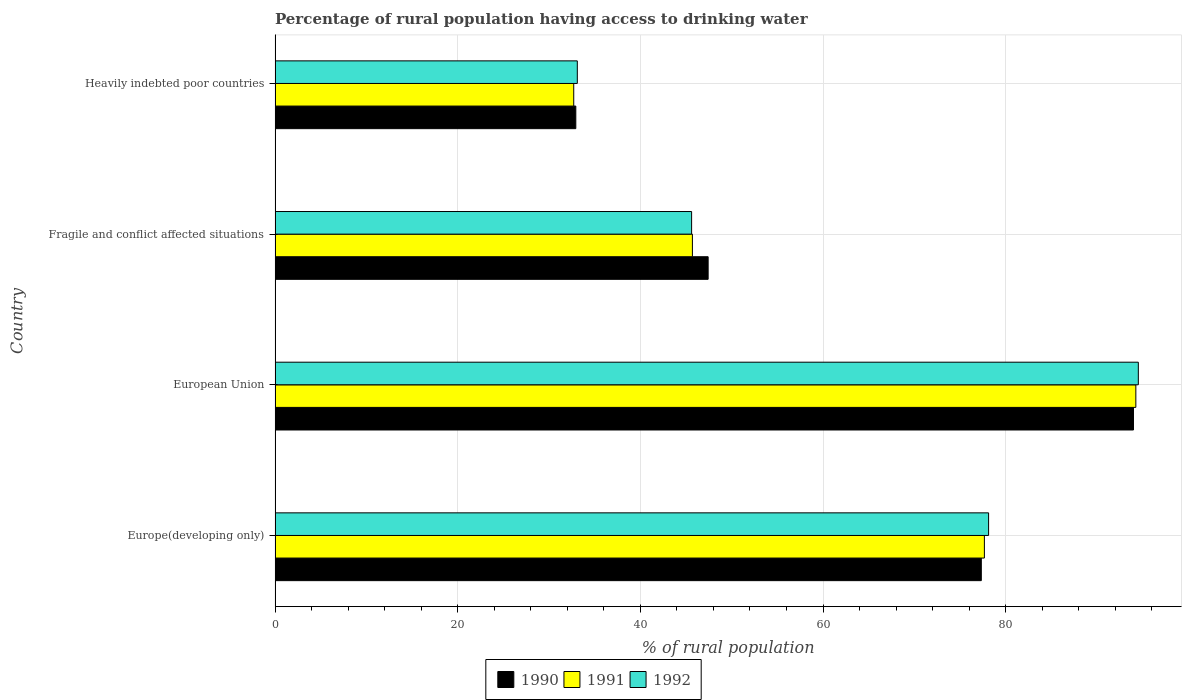How many bars are there on the 1st tick from the top?
Ensure brevity in your answer.  3. How many bars are there on the 2nd tick from the bottom?
Your response must be concise. 3. What is the label of the 3rd group of bars from the top?
Provide a short and direct response. European Union. What is the percentage of rural population having access to drinking water in 1991 in European Union?
Offer a very short reply. 94.25. Across all countries, what is the maximum percentage of rural population having access to drinking water in 1991?
Provide a short and direct response. 94.25. Across all countries, what is the minimum percentage of rural population having access to drinking water in 1990?
Ensure brevity in your answer.  32.93. In which country was the percentage of rural population having access to drinking water in 1992 minimum?
Ensure brevity in your answer.  Heavily indebted poor countries. What is the total percentage of rural population having access to drinking water in 1990 in the graph?
Ensure brevity in your answer.  251.68. What is the difference between the percentage of rural population having access to drinking water in 1991 in Fragile and conflict affected situations and that in Heavily indebted poor countries?
Offer a very short reply. 12.99. What is the difference between the percentage of rural population having access to drinking water in 1990 in European Union and the percentage of rural population having access to drinking water in 1992 in Fragile and conflict affected situations?
Keep it short and to the point. 48.38. What is the average percentage of rural population having access to drinking water in 1991 per country?
Your answer should be very brief. 62.58. What is the difference between the percentage of rural population having access to drinking water in 1992 and percentage of rural population having access to drinking water in 1991 in Fragile and conflict affected situations?
Provide a succinct answer. -0.09. In how many countries, is the percentage of rural population having access to drinking water in 1990 greater than 16 %?
Offer a very short reply. 4. What is the ratio of the percentage of rural population having access to drinking water in 1990 in European Union to that in Fragile and conflict affected situations?
Give a very brief answer. 1.98. Is the difference between the percentage of rural population having access to drinking water in 1992 in Fragile and conflict affected situations and Heavily indebted poor countries greater than the difference between the percentage of rural population having access to drinking water in 1991 in Fragile and conflict affected situations and Heavily indebted poor countries?
Provide a short and direct response. No. What is the difference between the highest and the second highest percentage of rural population having access to drinking water in 1990?
Offer a terse response. 16.66. What is the difference between the highest and the lowest percentage of rural population having access to drinking water in 1991?
Provide a succinct answer. 61.55. In how many countries, is the percentage of rural population having access to drinking water in 1990 greater than the average percentage of rural population having access to drinking water in 1990 taken over all countries?
Ensure brevity in your answer.  2. Is the sum of the percentage of rural population having access to drinking water in 1991 in European Union and Heavily indebted poor countries greater than the maximum percentage of rural population having access to drinking water in 1992 across all countries?
Keep it short and to the point. Yes. What does the 2nd bar from the bottom in Fragile and conflict affected situations represents?
Your answer should be compact. 1991. Is it the case that in every country, the sum of the percentage of rural population having access to drinking water in 1992 and percentage of rural population having access to drinking water in 1991 is greater than the percentage of rural population having access to drinking water in 1990?
Provide a short and direct response. Yes. Are all the bars in the graph horizontal?
Your answer should be compact. Yes. What is the difference between two consecutive major ticks on the X-axis?
Your answer should be very brief. 20. Are the values on the major ticks of X-axis written in scientific E-notation?
Keep it short and to the point. No. Does the graph contain grids?
Your response must be concise. Yes. Where does the legend appear in the graph?
Give a very brief answer. Bottom center. How many legend labels are there?
Offer a terse response. 3. How are the legend labels stacked?
Offer a very short reply. Horizontal. What is the title of the graph?
Make the answer very short. Percentage of rural population having access to drinking water. Does "2009" appear as one of the legend labels in the graph?
Your answer should be very brief. No. What is the label or title of the X-axis?
Your response must be concise. % of rural population. What is the % of rural population of 1990 in Europe(developing only)?
Ensure brevity in your answer.  77.33. What is the % of rural population in 1991 in Europe(developing only)?
Make the answer very short. 77.67. What is the % of rural population in 1992 in Europe(developing only)?
Provide a short and direct response. 78.13. What is the % of rural population of 1990 in European Union?
Keep it short and to the point. 93.99. What is the % of rural population of 1991 in European Union?
Provide a short and direct response. 94.25. What is the % of rural population in 1992 in European Union?
Offer a terse response. 94.53. What is the % of rural population of 1990 in Fragile and conflict affected situations?
Keep it short and to the point. 47.42. What is the % of rural population of 1991 in Fragile and conflict affected situations?
Make the answer very short. 45.7. What is the % of rural population in 1992 in Fragile and conflict affected situations?
Offer a terse response. 45.61. What is the % of rural population of 1990 in Heavily indebted poor countries?
Keep it short and to the point. 32.93. What is the % of rural population in 1991 in Heavily indebted poor countries?
Provide a succinct answer. 32.7. What is the % of rural population of 1992 in Heavily indebted poor countries?
Offer a terse response. 33.09. Across all countries, what is the maximum % of rural population in 1990?
Offer a terse response. 93.99. Across all countries, what is the maximum % of rural population in 1991?
Offer a very short reply. 94.25. Across all countries, what is the maximum % of rural population of 1992?
Give a very brief answer. 94.53. Across all countries, what is the minimum % of rural population of 1990?
Offer a terse response. 32.93. Across all countries, what is the minimum % of rural population in 1991?
Offer a very short reply. 32.7. Across all countries, what is the minimum % of rural population in 1992?
Make the answer very short. 33.09. What is the total % of rural population of 1990 in the graph?
Provide a short and direct response. 251.68. What is the total % of rural population in 1991 in the graph?
Your response must be concise. 250.32. What is the total % of rural population in 1992 in the graph?
Provide a short and direct response. 251.36. What is the difference between the % of rural population in 1990 in Europe(developing only) and that in European Union?
Keep it short and to the point. -16.66. What is the difference between the % of rural population in 1991 in Europe(developing only) and that in European Union?
Provide a succinct answer. -16.59. What is the difference between the % of rural population in 1992 in Europe(developing only) and that in European Union?
Ensure brevity in your answer.  -16.4. What is the difference between the % of rural population in 1990 in Europe(developing only) and that in Fragile and conflict affected situations?
Make the answer very short. 29.91. What is the difference between the % of rural population of 1991 in Europe(developing only) and that in Fragile and conflict affected situations?
Give a very brief answer. 31.97. What is the difference between the % of rural population in 1992 in Europe(developing only) and that in Fragile and conflict affected situations?
Ensure brevity in your answer.  32.52. What is the difference between the % of rural population in 1990 in Europe(developing only) and that in Heavily indebted poor countries?
Ensure brevity in your answer.  44.4. What is the difference between the % of rural population in 1991 in Europe(developing only) and that in Heavily indebted poor countries?
Offer a very short reply. 44.97. What is the difference between the % of rural population of 1992 in Europe(developing only) and that in Heavily indebted poor countries?
Ensure brevity in your answer.  45.04. What is the difference between the % of rural population of 1990 in European Union and that in Fragile and conflict affected situations?
Your answer should be compact. 46.57. What is the difference between the % of rural population of 1991 in European Union and that in Fragile and conflict affected situations?
Keep it short and to the point. 48.56. What is the difference between the % of rural population of 1992 in European Union and that in Fragile and conflict affected situations?
Your answer should be compact. 48.92. What is the difference between the % of rural population in 1990 in European Union and that in Heavily indebted poor countries?
Your response must be concise. 61.06. What is the difference between the % of rural population of 1991 in European Union and that in Heavily indebted poor countries?
Offer a terse response. 61.55. What is the difference between the % of rural population of 1992 in European Union and that in Heavily indebted poor countries?
Your answer should be very brief. 61.43. What is the difference between the % of rural population in 1990 in Fragile and conflict affected situations and that in Heavily indebted poor countries?
Your answer should be compact. 14.49. What is the difference between the % of rural population of 1991 in Fragile and conflict affected situations and that in Heavily indebted poor countries?
Provide a short and direct response. 12.99. What is the difference between the % of rural population in 1992 in Fragile and conflict affected situations and that in Heavily indebted poor countries?
Provide a short and direct response. 12.52. What is the difference between the % of rural population of 1990 in Europe(developing only) and the % of rural population of 1991 in European Union?
Provide a succinct answer. -16.92. What is the difference between the % of rural population in 1990 in Europe(developing only) and the % of rural population in 1992 in European Union?
Your response must be concise. -17.19. What is the difference between the % of rural population of 1991 in Europe(developing only) and the % of rural population of 1992 in European Union?
Give a very brief answer. -16.86. What is the difference between the % of rural population of 1990 in Europe(developing only) and the % of rural population of 1991 in Fragile and conflict affected situations?
Offer a very short reply. 31.64. What is the difference between the % of rural population of 1990 in Europe(developing only) and the % of rural population of 1992 in Fragile and conflict affected situations?
Provide a short and direct response. 31.72. What is the difference between the % of rural population of 1991 in Europe(developing only) and the % of rural population of 1992 in Fragile and conflict affected situations?
Your answer should be very brief. 32.06. What is the difference between the % of rural population of 1990 in Europe(developing only) and the % of rural population of 1991 in Heavily indebted poor countries?
Provide a short and direct response. 44.63. What is the difference between the % of rural population in 1990 in Europe(developing only) and the % of rural population in 1992 in Heavily indebted poor countries?
Your response must be concise. 44.24. What is the difference between the % of rural population of 1991 in Europe(developing only) and the % of rural population of 1992 in Heavily indebted poor countries?
Provide a short and direct response. 44.57. What is the difference between the % of rural population of 1990 in European Union and the % of rural population of 1991 in Fragile and conflict affected situations?
Your response must be concise. 48.3. What is the difference between the % of rural population of 1990 in European Union and the % of rural population of 1992 in Fragile and conflict affected situations?
Your response must be concise. 48.38. What is the difference between the % of rural population in 1991 in European Union and the % of rural population in 1992 in Fragile and conflict affected situations?
Ensure brevity in your answer.  48.64. What is the difference between the % of rural population of 1990 in European Union and the % of rural population of 1991 in Heavily indebted poor countries?
Your answer should be compact. 61.29. What is the difference between the % of rural population of 1990 in European Union and the % of rural population of 1992 in Heavily indebted poor countries?
Ensure brevity in your answer.  60.9. What is the difference between the % of rural population of 1991 in European Union and the % of rural population of 1992 in Heavily indebted poor countries?
Make the answer very short. 61.16. What is the difference between the % of rural population of 1990 in Fragile and conflict affected situations and the % of rural population of 1991 in Heavily indebted poor countries?
Offer a very short reply. 14.72. What is the difference between the % of rural population in 1990 in Fragile and conflict affected situations and the % of rural population in 1992 in Heavily indebted poor countries?
Your answer should be compact. 14.33. What is the difference between the % of rural population in 1991 in Fragile and conflict affected situations and the % of rural population in 1992 in Heavily indebted poor countries?
Keep it short and to the point. 12.6. What is the average % of rural population in 1990 per country?
Your answer should be very brief. 62.92. What is the average % of rural population of 1991 per country?
Your answer should be compact. 62.58. What is the average % of rural population of 1992 per country?
Offer a very short reply. 62.84. What is the difference between the % of rural population in 1990 and % of rural population in 1991 in Europe(developing only)?
Your answer should be compact. -0.34. What is the difference between the % of rural population of 1990 and % of rural population of 1992 in Europe(developing only)?
Make the answer very short. -0.8. What is the difference between the % of rural population of 1991 and % of rural population of 1992 in Europe(developing only)?
Provide a short and direct response. -0.46. What is the difference between the % of rural population of 1990 and % of rural population of 1991 in European Union?
Provide a short and direct response. -0.26. What is the difference between the % of rural population of 1990 and % of rural population of 1992 in European Union?
Keep it short and to the point. -0.53. What is the difference between the % of rural population in 1991 and % of rural population in 1992 in European Union?
Your answer should be very brief. -0.27. What is the difference between the % of rural population in 1990 and % of rural population in 1991 in Fragile and conflict affected situations?
Provide a short and direct response. 1.72. What is the difference between the % of rural population in 1990 and % of rural population in 1992 in Fragile and conflict affected situations?
Make the answer very short. 1.81. What is the difference between the % of rural population of 1991 and % of rural population of 1992 in Fragile and conflict affected situations?
Provide a succinct answer. 0.09. What is the difference between the % of rural population in 1990 and % of rural population in 1991 in Heavily indebted poor countries?
Ensure brevity in your answer.  0.23. What is the difference between the % of rural population in 1990 and % of rural population in 1992 in Heavily indebted poor countries?
Offer a terse response. -0.16. What is the difference between the % of rural population in 1991 and % of rural population in 1992 in Heavily indebted poor countries?
Your response must be concise. -0.39. What is the ratio of the % of rural population in 1990 in Europe(developing only) to that in European Union?
Make the answer very short. 0.82. What is the ratio of the % of rural population of 1991 in Europe(developing only) to that in European Union?
Your response must be concise. 0.82. What is the ratio of the % of rural population in 1992 in Europe(developing only) to that in European Union?
Offer a terse response. 0.83. What is the ratio of the % of rural population of 1990 in Europe(developing only) to that in Fragile and conflict affected situations?
Offer a terse response. 1.63. What is the ratio of the % of rural population of 1991 in Europe(developing only) to that in Fragile and conflict affected situations?
Your answer should be very brief. 1.7. What is the ratio of the % of rural population in 1992 in Europe(developing only) to that in Fragile and conflict affected situations?
Your answer should be very brief. 1.71. What is the ratio of the % of rural population in 1990 in Europe(developing only) to that in Heavily indebted poor countries?
Provide a short and direct response. 2.35. What is the ratio of the % of rural population of 1991 in Europe(developing only) to that in Heavily indebted poor countries?
Make the answer very short. 2.38. What is the ratio of the % of rural population in 1992 in Europe(developing only) to that in Heavily indebted poor countries?
Provide a short and direct response. 2.36. What is the ratio of the % of rural population in 1990 in European Union to that in Fragile and conflict affected situations?
Your response must be concise. 1.98. What is the ratio of the % of rural population in 1991 in European Union to that in Fragile and conflict affected situations?
Make the answer very short. 2.06. What is the ratio of the % of rural population in 1992 in European Union to that in Fragile and conflict affected situations?
Make the answer very short. 2.07. What is the ratio of the % of rural population in 1990 in European Union to that in Heavily indebted poor countries?
Offer a terse response. 2.85. What is the ratio of the % of rural population of 1991 in European Union to that in Heavily indebted poor countries?
Give a very brief answer. 2.88. What is the ratio of the % of rural population in 1992 in European Union to that in Heavily indebted poor countries?
Offer a very short reply. 2.86. What is the ratio of the % of rural population in 1990 in Fragile and conflict affected situations to that in Heavily indebted poor countries?
Offer a very short reply. 1.44. What is the ratio of the % of rural population of 1991 in Fragile and conflict affected situations to that in Heavily indebted poor countries?
Ensure brevity in your answer.  1.4. What is the ratio of the % of rural population in 1992 in Fragile and conflict affected situations to that in Heavily indebted poor countries?
Your response must be concise. 1.38. What is the difference between the highest and the second highest % of rural population of 1990?
Offer a very short reply. 16.66. What is the difference between the highest and the second highest % of rural population of 1991?
Provide a succinct answer. 16.59. What is the difference between the highest and the second highest % of rural population in 1992?
Give a very brief answer. 16.4. What is the difference between the highest and the lowest % of rural population of 1990?
Keep it short and to the point. 61.06. What is the difference between the highest and the lowest % of rural population of 1991?
Your answer should be compact. 61.55. What is the difference between the highest and the lowest % of rural population of 1992?
Your answer should be compact. 61.43. 